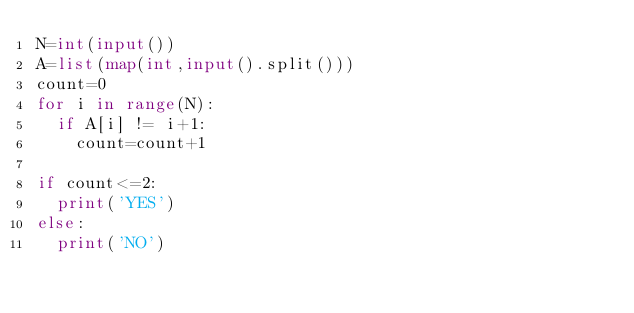<code> <loc_0><loc_0><loc_500><loc_500><_Python_>N=int(input())
A=list(map(int,input().split()))
count=0
for i in range(N):
  if A[i] != i+1:
    count=count+1
  
if count<=2:
  print('YES')
else:
  print('NO')</code> 